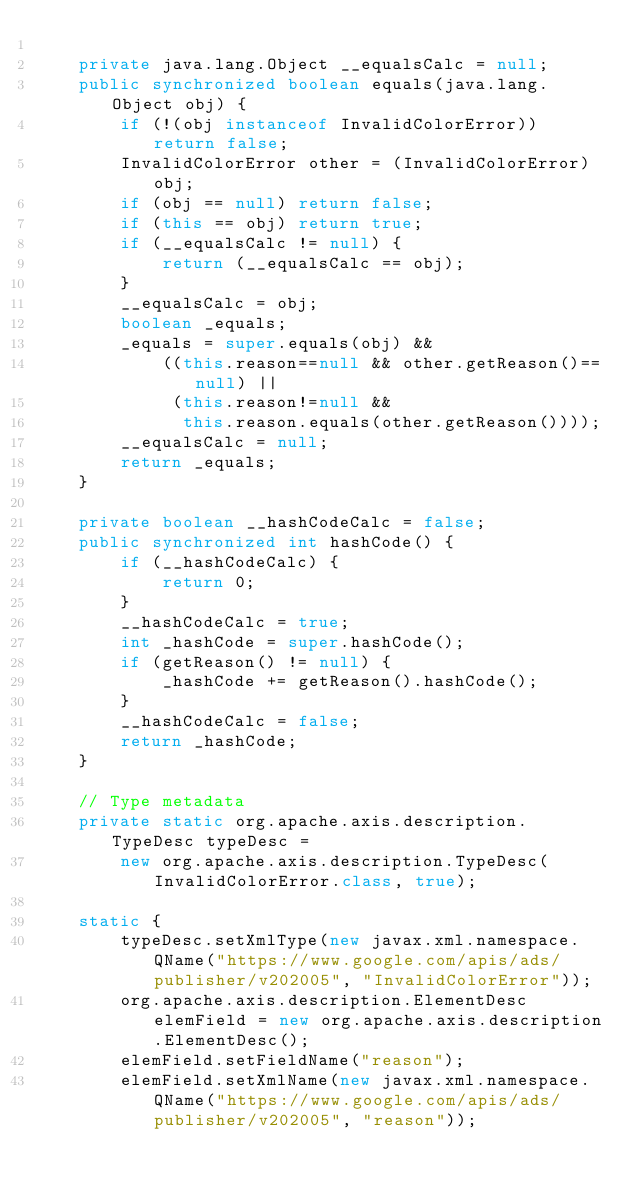Convert code to text. <code><loc_0><loc_0><loc_500><loc_500><_Java_>
    private java.lang.Object __equalsCalc = null;
    public synchronized boolean equals(java.lang.Object obj) {
        if (!(obj instanceof InvalidColorError)) return false;
        InvalidColorError other = (InvalidColorError) obj;
        if (obj == null) return false;
        if (this == obj) return true;
        if (__equalsCalc != null) {
            return (__equalsCalc == obj);
        }
        __equalsCalc = obj;
        boolean _equals;
        _equals = super.equals(obj) && 
            ((this.reason==null && other.getReason()==null) || 
             (this.reason!=null &&
              this.reason.equals(other.getReason())));
        __equalsCalc = null;
        return _equals;
    }

    private boolean __hashCodeCalc = false;
    public synchronized int hashCode() {
        if (__hashCodeCalc) {
            return 0;
        }
        __hashCodeCalc = true;
        int _hashCode = super.hashCode();
        if (getReason() != null) {
            _hashCode += getReason().hashCode();
        }
        __hashCodeCalc = false;
        return _hashCode;
    }

    // Type metadata
    private static org.apache.axis.description.TypeDesc typeDesc =
        new org.apache.axis.description.TypeDesc(InvalidColorError.class, true);

    static {
        typeDesc.setXmlType(new javax.xml.namespace.QName("https://www.google.com/apis/ads/publisher/v202005", "InvalidColorError"));
        org.apache.axis.description.ElementDesc elemField = new org.apache.axis.description.ElementDesc();
        elemField.setFieldName("reason");
        elemField.setXmlName(new javax.xml.namespace.QName("https://www.google.com/apis/ads/publisher/v202005", "reason"));</code> 